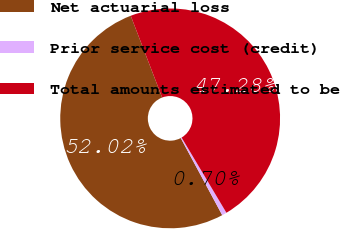Convert chart. <chart><loc_0><loc_0><loc_500><loc_500><pie_chart><fcel>Net actuarial loss<fcel>Prior service cost (credit)<fcel>Total amounts estimated to be<nl><fcel>52.01%<fcel>0.7%<fcel>47.28%<nl></chart> 